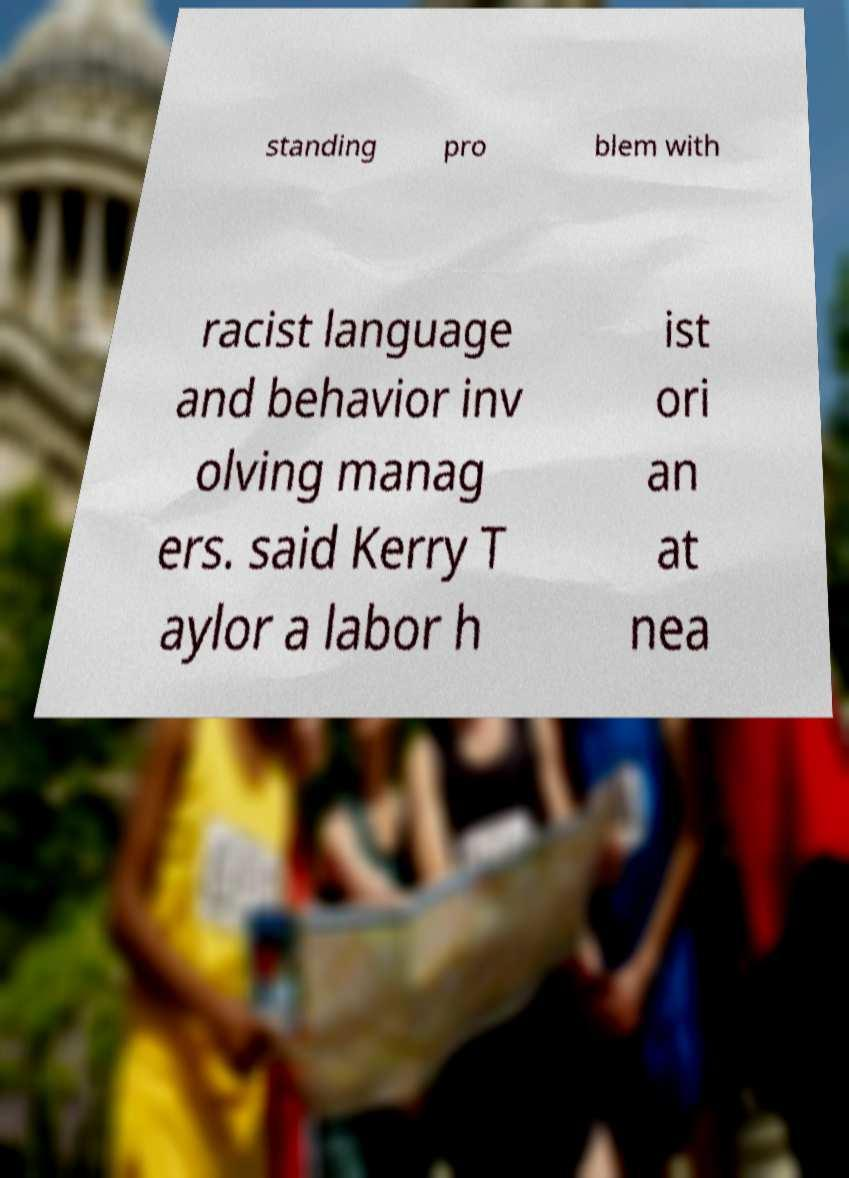Please read and relay the text visible in this image. What does it say? standing pro blem with racist language and behavior inv olving manag ers. said Kerry T aylor a labor h ist ori an at nea 